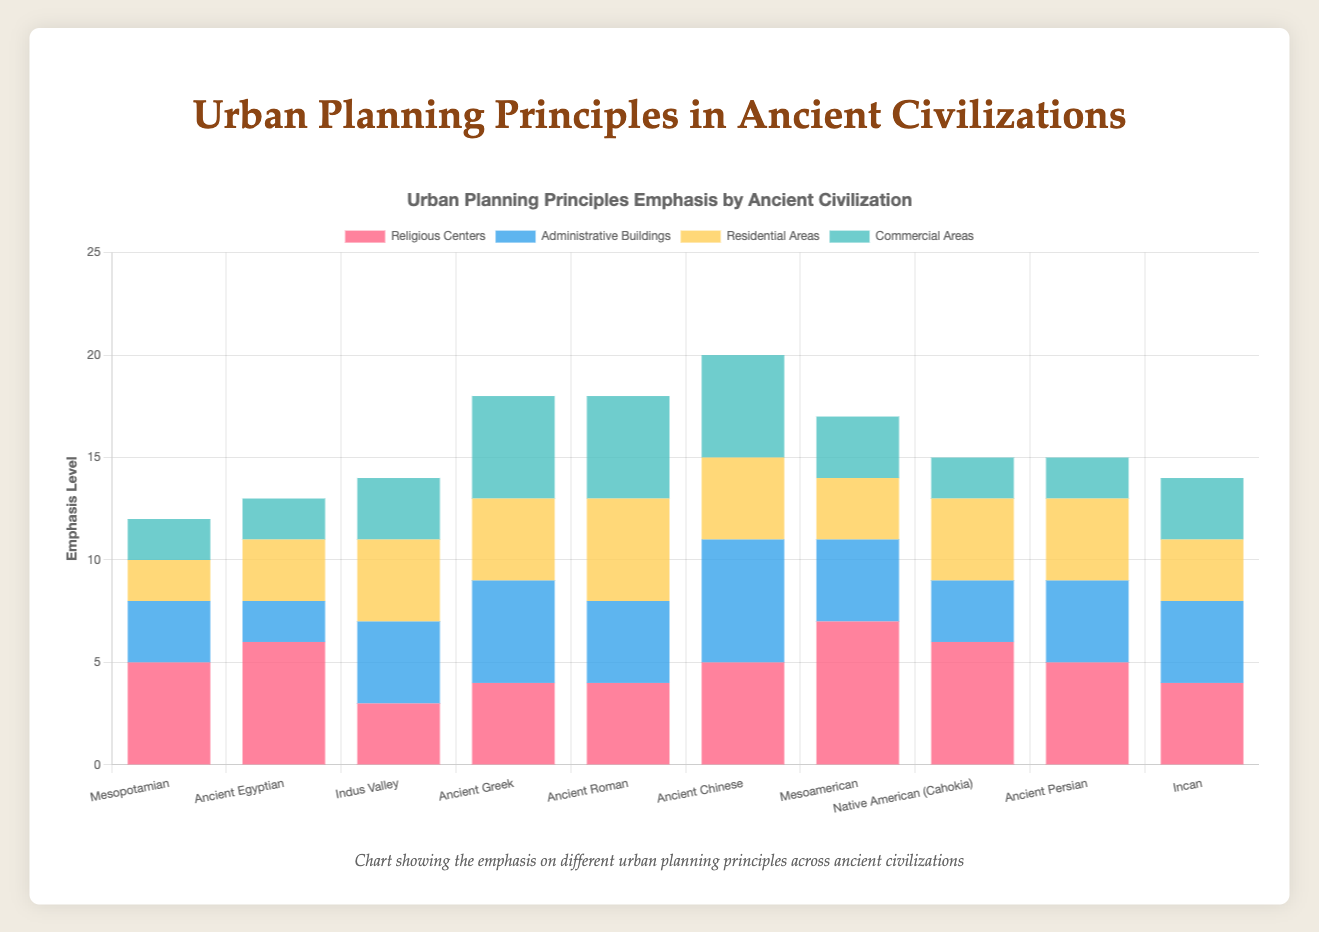Which culture places the greatest emphasis on Religious Centers? Observe the data points associated with each culture for the Religious Centers category. The Mesoamerican culture has the highest bar (most emphasis) at 7.
Answer: Mesoamerican Which culture has the least emphasis on Commercial Areas? Observe the smallest bar in the Commercial Areas category across all cultures. The Mesopotamian, Ancient Egyptian, Native American (Cahokia), and Ancient Persian cultures all have the smallest bars at 2.
Answer: Mesopotamian, Ancient Egyptian, Native American (Cahokia), Ancient Persian What is the total emphasis on Administrative Buildings and Residential Areas for the Ancient Greek culture? Sum the values of Administrative Buildings and Residential Areas for the Ancient Greek culture. It is 5 (Administrative Buildings) + 4 (Residential Areas) = 9.
Answer: 9 Which civilization has an equal emphasis on both Residential Areas and Commercial Areas? Look for bars of equal height in the Residential Areas and Commercial Areas categories for each culture. Ancient Greek has equal emphasis of 4 for both categories.
Answer: Ancient Greek What is the difference between the highest emphasis on Religious Centers and the lowest emphasis on Residential Areas? Identify the highest value for Religious Centers, which is 7 (Mesoamerican), and the lowest value for Residential Areas, which is 2 (Mesopotamian). The difference is 7 - 2 = 5.
Answer: 5 Identify a culture where the emphasis on Religious Centers is greater than on Administrative Buildings by exactly 2 units. Look for a culture where the difference between Religious Centers and Administrative Buildings is exactly 2. For the Ancient Egyptian: 6 (Religious Centers) - 2 (Administrative Buildings) = 4; for Mesopotamian: 5 (Religious Centers) - 3 (Administrative Buildings) = 2.
Answer: Mesopotamian 